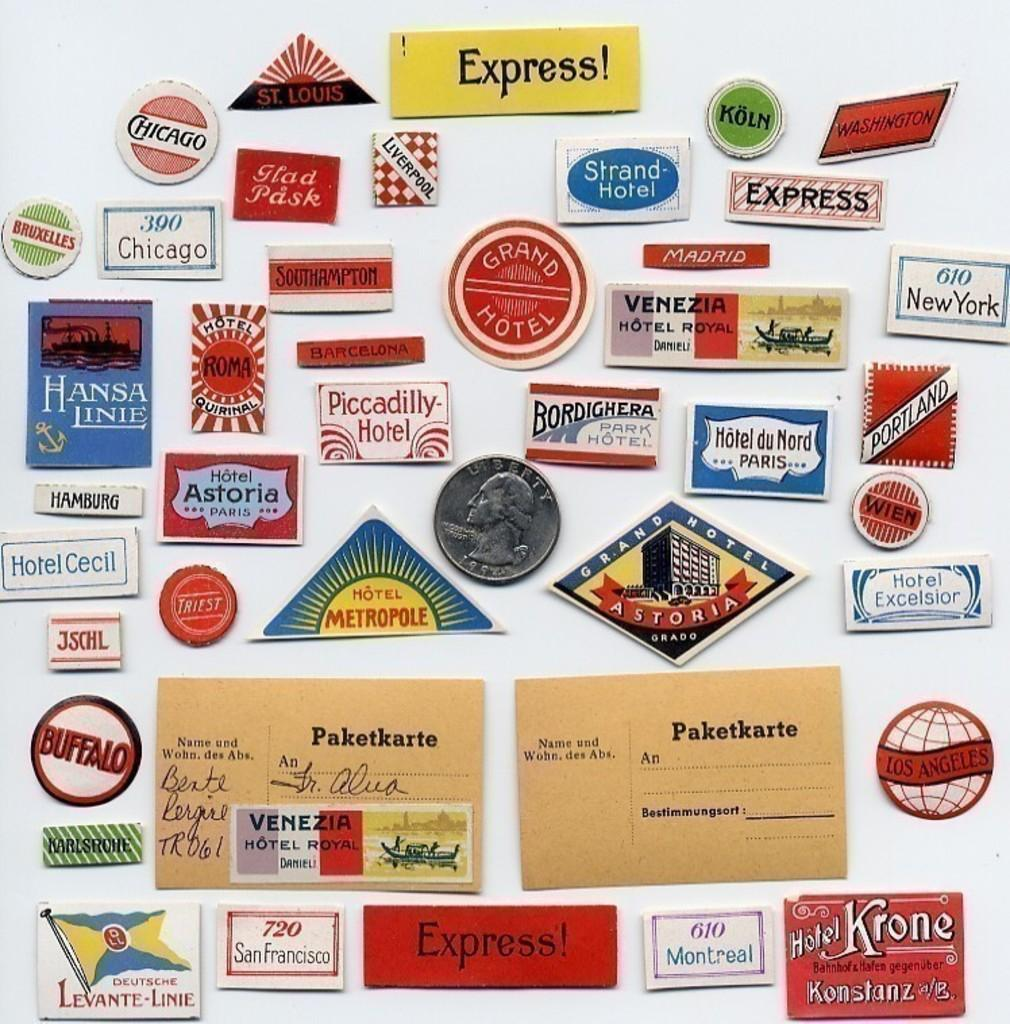<image>
Write a terse but informative summary of the picture. Square labels with a silver quarter in the middle that has Liberty on it. 